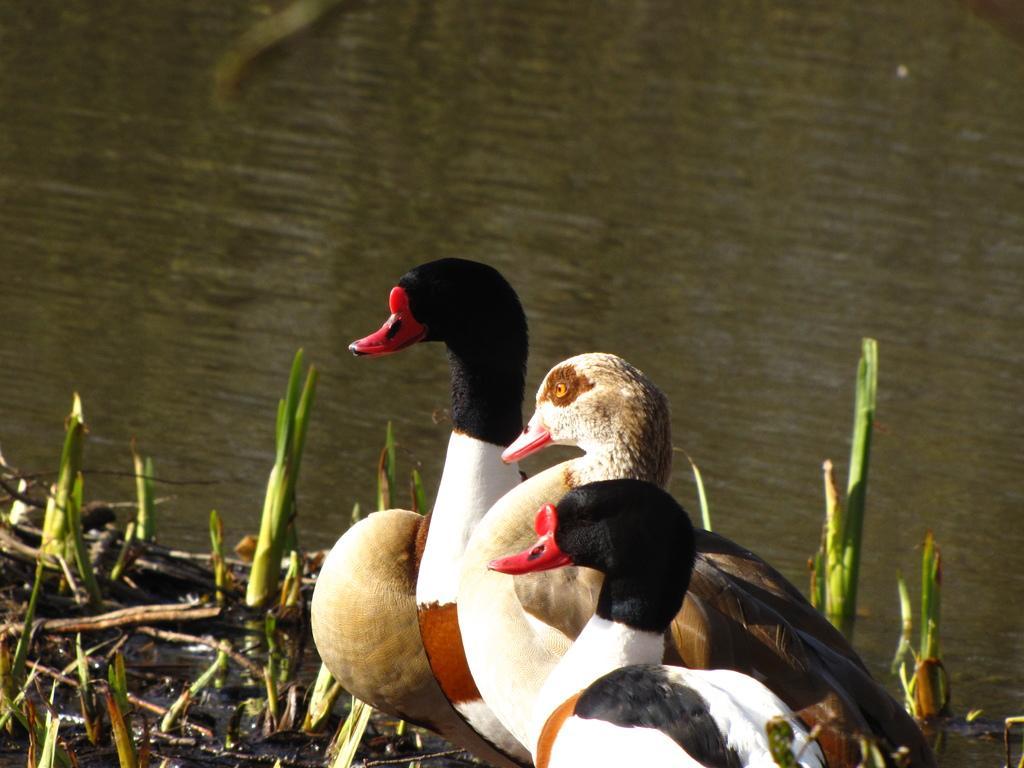In one or two sentences, can you explain what this image depicts? In this image I can see few birds and they are in black, white and brown color. Background I can see the grass in green color and I can also see the water. 